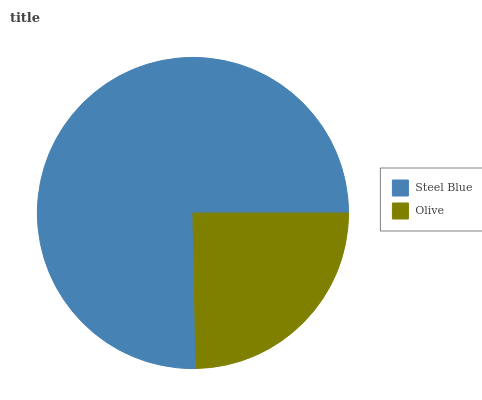Is Olive the minimum?
Answer yes or no. Yes. Is Steel Blue the maximum?
Answer yes or no. Yes. Is Olive the maximum?
Answer yes or no. No. Is Steel Blue greater than Olive?
Answer yes or no. Yes. Is Olive less than Steel Blue?
Answer yes or no. Yes. Is Olive greater than Steel Blue?
Answer yes or no. No. Is Steel Blue less than Olive?
Answer yes or no. No. Is Steel Blue the high median?
Answer yes or no. Yes. Is Olive the low median?
Answer yes or no. Yes. Is Olive the high median?
Answer yes or no. No. Is Steel Blue the low median?
Answer yes or no. No. 